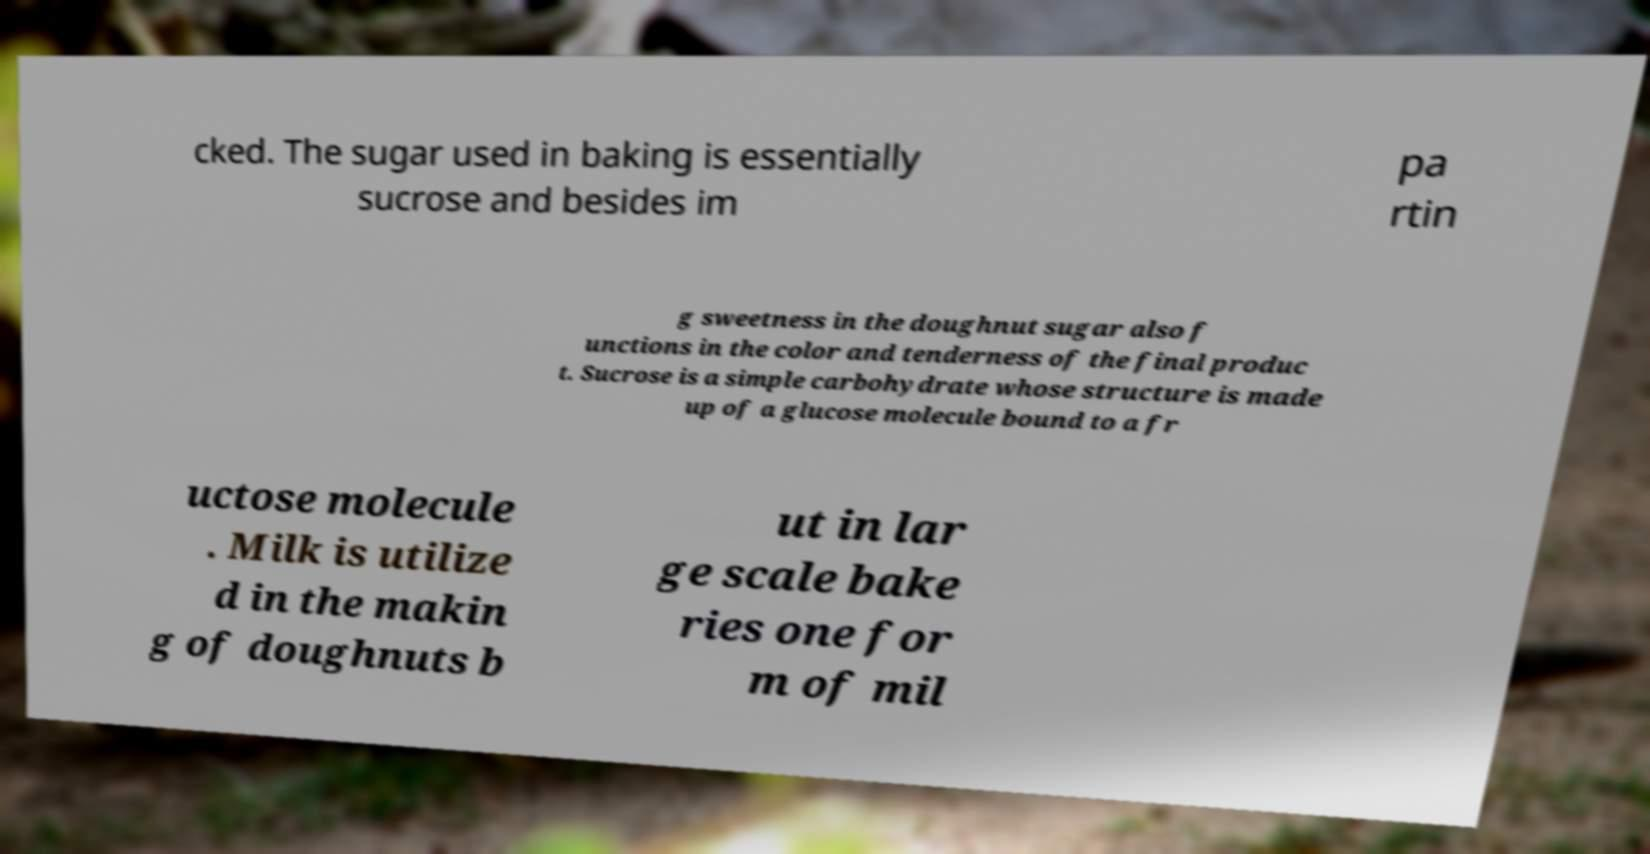Can you read and provide the text displayed in the image?This photo seems to have some interesting text. Can you extract and type it out for me? cked. The sugar used in baking is essentially sucrose and besides im pa rtin g sweetness in the doughnut sugar also f unctions in the color and tenderness of the final produc t. Sucrose is a simple carbohydrate whose structure is made up of a glucose molecule bound to a fr uctose molecule . Milk is utilize d in the makin g of doughnuts b ut in lar ge scale bake ries one for m of mil 